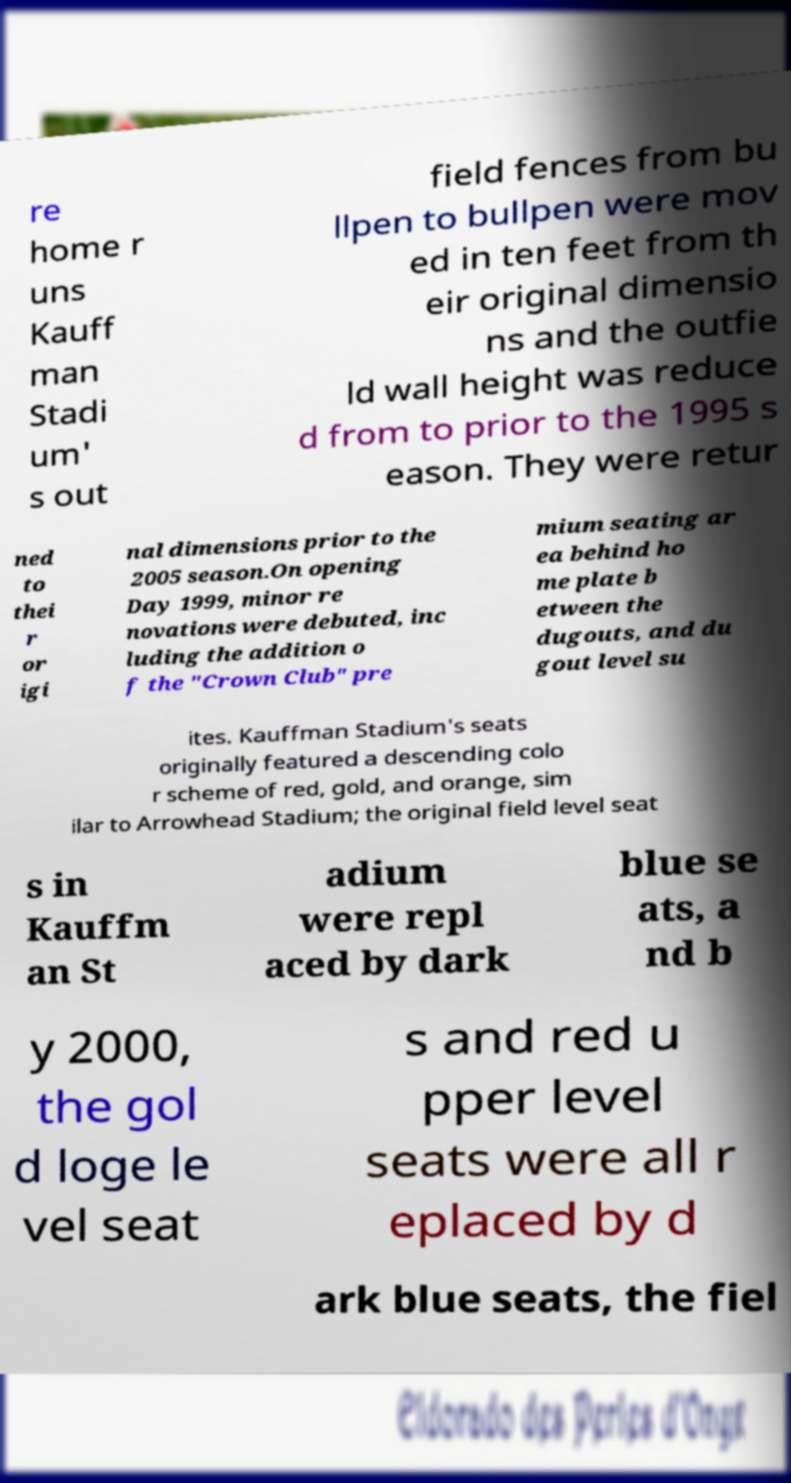Please read and relay the text visible in this image. What does it say? re home r uns Kauff man Stadi um' s out field fences from bu llpen to bullpen were mov ed in ten feet from th eir original dimensio ns and the outfie ld wall height was reduce d from to prior to the 1995 s eason. They were retur ned to thei r or igi nal dimensions prior to the 2005 season.On opening Day 1999, minor re novations were debuted, inc luding the addition o f the "Crown Club" pre mium seating ar ea behind ho me plate b etween the dugouts, and du gout level su ites. Kauffman Stadium's seats originally featured a descending colo r scheme of red, gold, and orange, sim ilar to Arrowhead Stadium; the original field level seat s in Kauffm an St adium were repl aced by dark blue se ats, a nd b y 2000, the gol d loge le vel seat s and red u pper level seats were all r eplaced by d ark blue seats, the fiel 